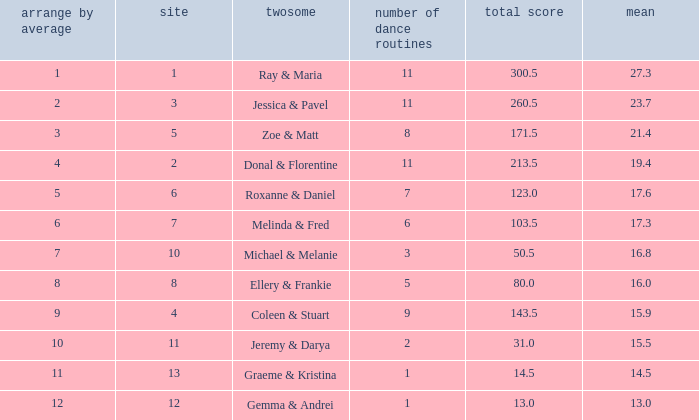If the total points is 50.5, what is the total number of dances? 1.0. 